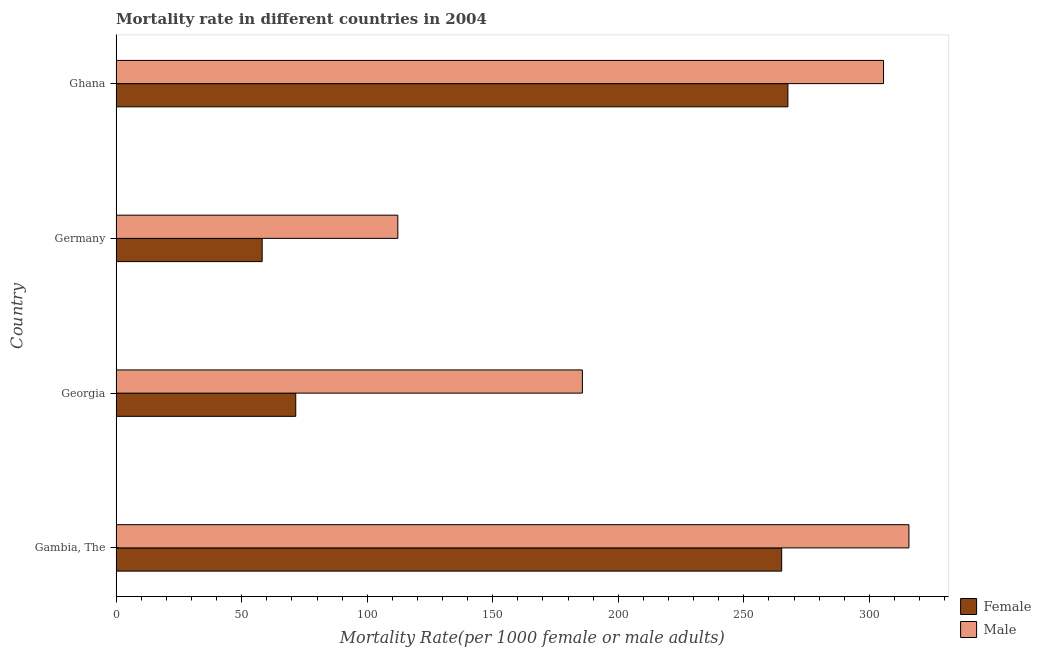How many groups of bars are there?
Provide a succinct answer. 4. Are the number of bars per tick equal to the number of legend labels?
Keep it short and to the point. Yes. How many bars are there on the 2nd tick from the top?
Provide a succinct answer. 2. What is the label of the 3rd group of bars from the top?
Offer a very short reply. Georgia. What is the female mortality rate in Georgia?
Ensure brevity in your answer.  71.54. Across all countries, what is the maximum female mortality rate?
Make the answer very short. 267.55. Across all countries, what is the minimum female mortality rate?
Provide a short and direct response. 58.16. In which country was the female mortality rate maximum?
Make the answer very short. Ghana. What is the total male mortality rate in the graph?
Offer a terse response. 919.29. What is the difference between the female mortality rate in Georgia and that in Ghana?
Provide a short and direct response. -196.01. What is the difference between the male mortality rate in Gambia, The and the female mortality rate in Georgia?
Offer a terse response. 244.22. What is the average male mortality rate per country?
Offer a very short reply. 229.82. What is the difference between the female mortality rate and male mortality rate in Gambia, The?
Offer a terse response. -50.68. What is the ratio of the female mortality rate in Georgia to that in Ghana?
Give a very brief answer. 0.27. Is the female mortality rate in Gambia, The less than that in Ghana?
Your response must be concise. Yes. Is the difference between the female mortality rate in Georgia and Germany greater than the difference between the male mortality rate in Georgia and Germany?
Ensure brevity in your answer.  No. What is the difference between the highest and the second highest female mortality rate?
Ensure brevity in your answer.  2.48. What is the difference between the highest and the lowest male mortality rate?
Your response must be concise. 203.56. What does the 1st bar from the top in Ghana represents?
Make the answer very short. Male. What does the 2nd bar from the bottom in Ghana represents?
Offer a terse response. Male. How many bars are there?
Offer a very short reply. 8. Are all the bars in the graph horizontal?
Your answer should be compact. Yes. How many countries are there in the graph?
Your response must be concise. 4. Are the values on the major ticks of X-axis written in scientific E-notation?
Keep it short and to the point. No. Does the graph contain grids?
Your answer should be compact. No. Where does the legend appear in the graph?
Keep it short and to the point. Bottom right. How many legend labels are there?
Ensure brevity in your answer.  2. How are the legend labels stacked?
Give a very brief answer. Vertical. What is the title of the graph?
Provide a succinct answer. Mortality rate in different countries in 2004. Does "Secondary education" appear as one of the legend labels in the graph?
Provide a short and direct response. No. What is the label or title of the X-axis?
Provide a succinct answer. Mortality Rate(per 1000 female or male adults). What is the label or title of the Y-axis?
Provide a succinct answer. Country. What is the Mortality Rate(per 1000 female or male adults) of Female in Gambia, The?
Provide a short and direct response. 265.08. What is the Mortality Rate(per 1000 female or male adults) of Male in Gambia, The?
Provide a succinct answer. 315.76. What is the Mortality Rate(per 1000 female or male adults) in Female in Georgia?
Ensure brevity in your answer.  71.54. What is the Mortality Rate(per 1000 female or male adults) of Male in Georgia?
Your answer should be very brief. 185.7. What is the Mortality Rate(per 1000 female or male adults) in Female in Germany?
Ensure brevity in your answer.  58.16. What is the Mortality Rate(per 1000 female or male adults) of Male in Germany?
Offer a terse response. 112.2. What is the Mortality Rate(per 1000 female or male adults) in Female in Ghana?
Offer a very short reply. 267.55. What is the Mortality Rate(per 1000 female or male adults) in Male in Ghana?
Provide a succinct answer. 305.64. Across all countries, what is the maximum Mortality Rate(per 1000 female or male adults) in Female?
Give a very brief answer. 267.55. Across all countries, what is the maximum Mortality Rate(per 1000 female or male adults) of Male?
Offer a terse response. 315.76. Across all countries, what is the minimum Mortality Rate(per 1000 female or male adults) in Female?
Make the answer very short. 58.16. Across all countries, what is the minimum Mortality Rate(per 1000 female or male adults) in Male?
Make the answer very short. 112.2. What is the total Mortality Rate(per 1000 female or male adults) of Female in the graph?
Offer a terse response. 662.33. What is the total Mortality Rate(per 1000 female or male adults) of Male in the graph?
Offer a terse response. 919.29. What is the difference between the Mortality Rate(per 1000 female or male adults) of Female in Gambia, The and that in Georgia?
Provide a short and direct response. 193.54. What is the difference between the Mortality Rate(per 1000 female or male adults) of Male in Gambia, The and that in Georgia?
Give a very brief answer. 130.06. What is the difference between the Mortality Rate(per 1000 female or male adults) in Female in Gambia, The and that in Germany?
Provide a short and direct response. 206.91. What is the difference between the Mortality Rate(per 1000 female or male adults) in Male in Gambia, The and that in Germany?
Give a very brief answer. 203.56. What is the difference between the Mortality Rate(per 1000 female or male adults) in Female in Gambia, The and that in Ghana?
Keep it short and to the point. -2.48. What is the difference between the Mortality Rate(per 1000 female or male adults) of Male in Gambia, The and that in Ghana?
Offer a very short reply. 10.12. What is the difference between the Mortality Rate(per 1000 female or male adults) of Female in Georgia and that in Germany?
Your answer should be very brief. 13.37. What is the difference between the Mortality Rate(per 1000 female or male adults) in Male in Georgia and that in Germany?
Keep it short and to the point. 73.5. What is the difference between the Mortality Rate(per 1000 female or male adults) of Female in Georgia and that in Ghana?
Keep it short and to the point. -196.01. What is the difference between the Mortality Rate(per 1000 female or male adults) of Male in Georgia and that in Ghana?
Your response must be concise. -119.94. What is the difference between the Mortality Rate(per 1000 female or male adults) in Female in Germany and that in Ghana?
Ensure brevity in your answer.  -209.39. What is the difference between the Mortality Rate(per 1000 female or male adults) of Male in Germany and that in Ghana?
Your answer should be compact. -193.44. What is the difference between the Mortality Rate(per 1000 female or male adults) in Female in Gambia, The and the Mortality Rate(per 1000 female or male adults) in Male in Georgia?
Your answer should be compact. 79.38. What is the difference between the Mortality Rate(per 1000 female or male adults) of Female in Gambia, The and the Mortality Rate(per 1000 female or male adults) of Male in Germany?
Provide a succinct answer. 152.88. What is the difference between the Mortality Rate(per 1000 female or male adults) in Female in Gambia, The and the Mortality Rate(per 1000 female or male adults) in Male in Ghana?
Make the answer very short. -40.56. What is the difference between the Mortality Rate(per 1000 female or male adults) in Female in Georgia and the Mortality Rate(per 1000 female or male adults) in Male in Germany?
Provide a short and direct response. -40.66. What is the difference between the Mortality Rate(per 1000 female or male adults) in Female in Georgia and the Mortality Rate(per 1000 female or male adults) in Male in Ghana?
Offer a terse response. -234.1. What is the difference between the Mortality Rate(per 1000 female or male adults) of Female in Germany and the Mortality Rate(per 1000 female or male adults) of Male in Ghana?
Ensure brevity in your answer.  -247.47. What is the average Mortality Rate(per 1000 female or male adults) in Female per country?
Your answer should be very brief. 165.58. What is the average Mortality Rate(per 1000 female or male adults) of Male per country?
Offer a terse response. 229.82. What is the difference between the Mortality Rate(per 1000 female or male adults) in Female and Mortality Rate(per 1000 female or male adults) in Male in Gambia, The?
Provide a succinct answer. -50.68. What is the difference between the Mortality Rate(per 1000 female or male adults) in Female and Mortality Rate(per 1000 female or male adults) in Male in Georgia?
Ensure brevity in your answer.  -114.16. What is the difference between the Mortality Rate(per 1000 female or male adults) in Female and Mortality Rate(per 1000 female or male adults) in Male in Germany?
Provide a succinct answer. -54.03. What is the difference between the Mortality Rate(per 1000 female or male adults) in Female and Mortality Rate(per 1000 female or male adults) in Male in Ghana?
Your answer should be very brief. -38.09. What is the ratio of the Mortality Rate(per 1000 female or male adults) in Female in Gambia, The to that in Georgia?
Keep it short and to the point. 3.71. What is the ratio of the Mortality Rate(per 1000 female or male adults) in Male in Gambia, The to that in Georgia?
Ensure brevity in your answer.  1.7. What is the ratio of the Mortality Rate(per 1000 female or male adults) in Female in Gambia, The to that in Germany?
Your response must be concise. 4.56. What is the ratio of the Mortality Rate(per 1000 female or male adults) of Male in Gambia, The to that in Germany?
Keep it short and to the point. 2.81. What is the ratio of the Mortality Rate(per 1000 female or male adults) in Female in Gambia, The to that in Ghana?
Keep it short and to the point. 0.99. What is the ratio of the Mortality Rate(per 1000 female or male adults) of Male in Gambia, The to that in Ghana?
Offer a very short reply. 1.03. What is the ratio of the Mortality Rate(per 1000 female or male adults) in Female in Georgia to that in Germany?
Your response must be concise. 1.23. What is the ratio of the Mortality Rate(per 1000 female or male adults) in Male in Georgia to that in Germany?
Provide a short and direct response. 1.66. What is the ratio of the Mortality Rate(per 1000 female or male adults) of Female in Georgia to that in Ghana?
Your answer should be compact. 0.27. What is the ratio of the Mortality Rate(per 1000 female or male adults) in Male in Georgia to that in Ghana?
Keep it short and to the point. 0.61. What is the ratio of the Mortality Rate(per 1000 female or male adults) of Female in Germany to that in Ghana?
Your answer should be compact. 0.22. What is the ratio of the Mortality Rate(per 1000 female or male adults) of Male in Germany to that in Ghana?
Your answer should be very brief. 0.37. What is the difference between the highest and the second highest Mortality Rate(per 1000 female or male adults) in Female?
Provide a short and direct response. 2.48. What is the difference between the highest and the second highest Mortality Rate(per 1000 female or male adults) of Male?
Your response must be concise. 10.12. What is the difference between the highest and the lowest Mortality Rate(per 1000 female or male adults) of Female?
Offer a terse response. 209.39. What is the difference between the highest and the lowest Mortality Rate(per 1000 female or male adults) of Male?
Your answer should be very brief. 203.56. 